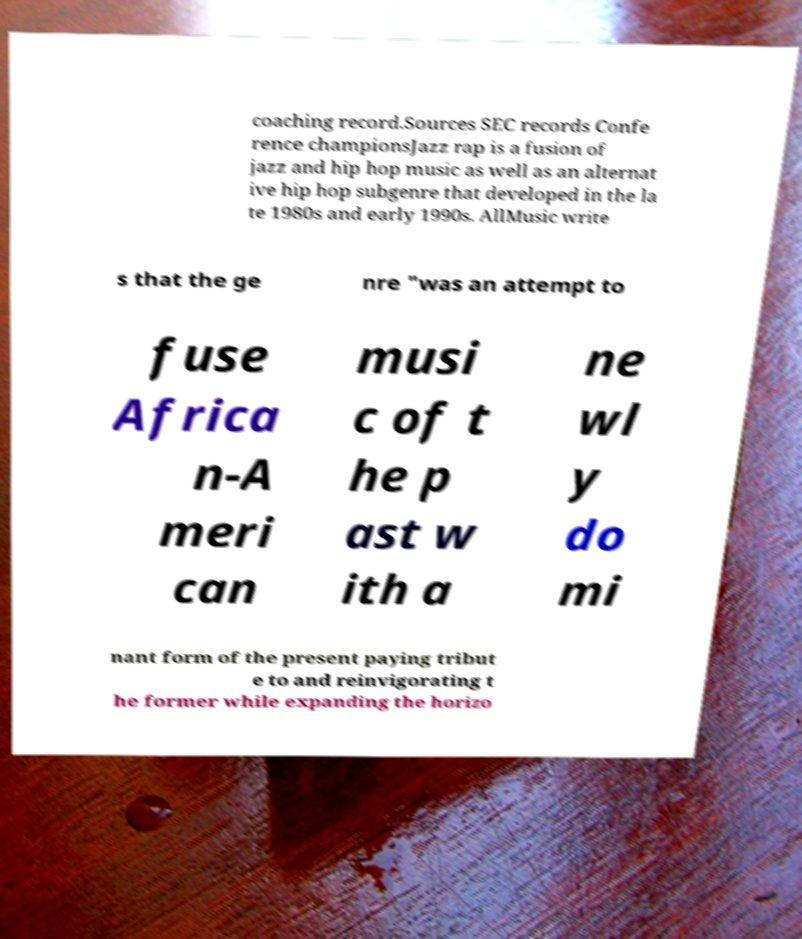Please identify and transcribe the text found in this image. coaching record.Sources SEC records Confe rence championsJazz rap is a fusion of jazz and hip hop music as well as an alternat ive hip hop subgenre that developed in the la te 1980s and early 1990s. AllMusic write s that the ge nre "was an attempt to fuse Africa n-A meri can musi c of t he p ast w ith a ne wl y do mi nant form of the present paying tribut e to and reinvigorating t he former while expanding the horizo 